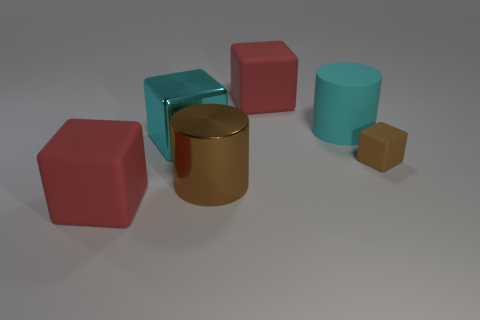The shiny object that is the same color as the matte cylinder is what shape?
Offer a terse response. Cube. What number of large cylinders have the same color as the tiny thing?
Your answer should be very brief. 1. What is the shape of the metallic object that is the same size as the brown cylinder?
Give a very brief answer. Cube. There is a big cyan shiny thing; are there any rubber cubes left of it?
Offer a very short reply. Yes. Do the brown rubber object and the cyan cylinder have the same size?
Make the answer very short. No. There is a red matte thing that is in front of the cyan matte thing; what shape is it?
Your answer should be very brief. Cube. Is there a cyan cylinder of the same size as the brown rubber thing?
Provide a short and direct response. No. What material is the cyan thing that is the same size as the rubber cylinder?
Give a very brief answer. Metal. How big is the red block that is left of the large brown metal thing?
Your answer should be compact. Large. How big is the brown metal object?
Your answer should be very brief. Large. 